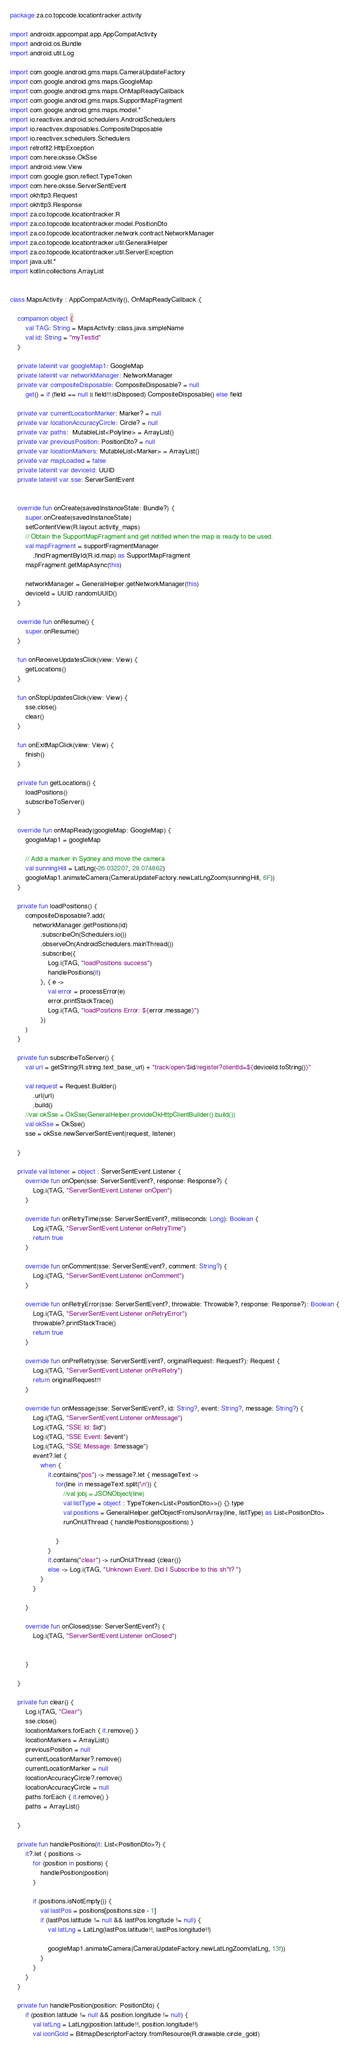Convert code to text. <code><loc_0><loc_0><loc_500><loc_500><_Kotlin_>package za.co.topcode.locationtracker.activity

import androidx.appcompat.app.AppCompatActivity
import android.os.Bundle
import android.util.Log

import com.google.android.gms.maps.CameraUpdateFactory
import com.google.android.gms.maps.GoogleMap
import com.google.android.gms.maps.OnMapReadyCallback
import com.google.android.gms.maps.SupportMapFragment
import com.google.android.gms.maps.model.*
import io.reactivex.android.schedulers.AndroidSchedulers
import io.reactivex.disposables.CompositeDisposable
import io.reactivex.schedulers.Schedulers
import retrofit2.HttpException
import com.here.oksse.OkSse
import android.view.View
import com.google.gson.reflect.TypeToken
import com.here.oksse.ServerSentEvent
import okhttp3.Request
import okhttp3.Response
import za.co.topcode.locationtracker.R
import za.co.topcode.locationtracker.model.PositionDto
import za.co.topcode.locationtracker.network.contract.NetworkManager
import za.co.topcode.locationtracker.util.GeneralHelper
import za.co.topcode.locationtracker.util.ServerException
import java.util.*
import kotlin.collections.ArrayList


class MapsActivity : AppCompatActivity(), OnMapReadyCallback {

    companion object {
        val TAG: String = MapsActivity::class.java.simpleName
        val id: String = "myTestId"
    }

    private lateinit var googleMap1: GoogleMap
    private lateinit var networkManager: NetworkManager
    private var compositeDisposable: CompositeDisposable? = null
        get() = if (field == null || field!!.isDisposed) CompositeDisposable() else field

    private var currentLocationMarker: Marker? = null
    private var locationAccuracyCircle: Circle? = null
    private var paths:  MutableList<Polyline> = ArrayList()
    private var previousPosition: PositionDto? = null
    private var locationMarkers: MutableList<Marker> = ArrayList()
    private var mapLoaded = false
    private lateinit var deviceId: UUID
    private lateinit var sse: ServerSentEvent


    override fun onCreate(savedInstanceState: Bundle?) {
        super.onCreate(savedInstanceState)
        setContentView(R.layout.activity_maps)
        // Obtain the SupportMapFragment and get notified when the map is ready to be used.
        val mapFragment = supportFragmentManager
            .findFragmentById(R.id.map) as SupportMapFragment
        mapFragment.getMapAsync(this)

        networkManager = GeneralHelper.getNetworkManager(this)
        deviceId = UUID.randomUUID()
    }

    override fun onResume() {
        super.onResume()
    }

    fun onReceiveUpdatesClick(view: View) {
        getLocations()
    }

    fun onStopUpdatesClick(view: View) {
        sse.close()
        clear()
    }

    fun onExitMapClick(view: View) {
        finish()
    }

    private fun getLocations() {
        loadPositions()
        subscribeToServer()
    }

    override fun onMapReady(googleMap: GoogleMap) {
        googleMap1 = googleMap

        // Add a marker in Sydney and move the camera
        val sunningHill = LatLng(-26.032207, 28.074862)
        googleMap1.animateCamera(CameraUpdateFactory.newLatLngZoom(sunningHill, 6F))
    }

    private fun loadPositions() {
        compositeDisposable?.add(
            networkManager.getPositions(id)
                .subscribeOn(Schedulers.io())
                .observeOn(AndroidSchedulers.mainThread())
                .subscribe({
                    Log.i(TAG, "loadPositions success")
                    handlePositions(it)
                }, { e ->
                    val error = processError(e)
                    error.printStackTrace()
                    Log.i(TAG, "loadPositions Error: ${error.message}")
                })
        )
    }

    private fun subscribeToServer() {
        val url = getString(R.string.text_base_url) + "track/open/$id/register?clientId=${deviceId.toString()}"

        val request = Request.Builder()
            .url(url)
            .build()
        //var okSse = OkSse(GeneralHelper.provideOkHttpClientBuilder().build())
        val okSse = OkSse()
        sse = okSse.newServerSentEvent(request, listener)

    }

    private val listener = object : ServerSentEvent.Listener {
        override fun onOpen(sse: ServerSentEvent?, response: Response?) {
            Log.i(TAG, "ServerSentEvent.Listener onOpen")
        }

        override fun onRetryTime(sse: ServerSentEvent?, milliseconds: Long): Boolean {
            Log.i(TAG, "ServerSentEvent.Listener onRetryTime")
            return true
        }

        override fun onComment(sse: ServerSentEvent?, comment: String?) {
            Log.i(TAG, "ServerSentEvent.Listener onComment")
        }

        override fun onRetryError(sse: ServerSentEvent?, throwable: Throwable?, response: Response?): Boolean {
            Log.i(TAG, "ServerSentEvent.Listener onRetryError")
            throwable?.printStackTrace()
            return true
        }

        override fun onPreRetry(sse: ServerSentEvent?, originalRequest: Request?): Request {
            Log.i(TAG, "ServerSentEvent.Listener onPreRetry")
            return originalRequest!!
        }

        override fun onMessage(sse: ServerSentEvent?, id: String?, event: String?, message: String?) {
            Log.i(TAG, "ServerSentEvent.Listener onMessage")
            Log.i(TAG, "SSE Id: $id")
            Log.i(TAG, "SSE Event: $event")
            Log.i(TAG, "SSE Message: $message")
            event?.let {
                when {
                    it.contains("pos") -> message?.let { messageText ->
                        for(line in messageText.split('\n')) {
                            //val jobj = JSONObject(line)
                            val listType = object : TypeToken<List<PositionDto>>() {}.type
                            val positions = GeneralHelper.getObjectFromJsonArray(line, listType) as List<PositionDto>
                            runOnUiThread { handlePositions(positions) }

                        }
                    }
                    it.contains("clear") -> runOnUiThread {clear()}
                    else -> Log.i(TAG, "Unknown Event. Did I Subscribe to this sh*t? ")
                }
            }

        }

        override fun onClosed(sse: ServerSentEvent?) {
            Log.i(TAG, "ServerSentEvent.Listener onClosed")


        }

    }

    private fun clear() {
        Log.i(TAG, "Clear")
        sse.close()
        locationMarkers.forEach { it.remove() }
        locationMarkers = ArrayList()
        previousPosition = null
        currentLocationMarker?.remove()
        currentLocationMarker = null
        locationAccuracyCircle?.remove()
        locationAccuracyCircle = null
        paths.forEach { it.remove() }
        paths = ArrayList()

    }

    private fun handlePositions(it: List<PositionDto>?) {
        it?.let { positions ->
            for (position in positions) {
                handlePosition(position)
            }

            if (positions.isNotEmpty()) {
                val lastPos = positions[positions.size - 1]
                if (lastPos.latitude != null && lastPos.longitude != null) {
                    val latLng = LatLng(lastPos.latitude!!, lastPos.longitude!!)

                    googleMap1.animateCamera(CameraUpdateFactory.newLatLngZoom(latLng, 13f))
                }
            }
        }
    }

    private fun handlePosition(position: PositionDto) {
        if (position.latitude != null && position.longitude != null) {
            val latLng = LatLng(position.latitude!!, position.longitude!!)
            val iconGold = BitmapDescriptorFactory.fromResource(R.drawable.circle_gold)</code> 